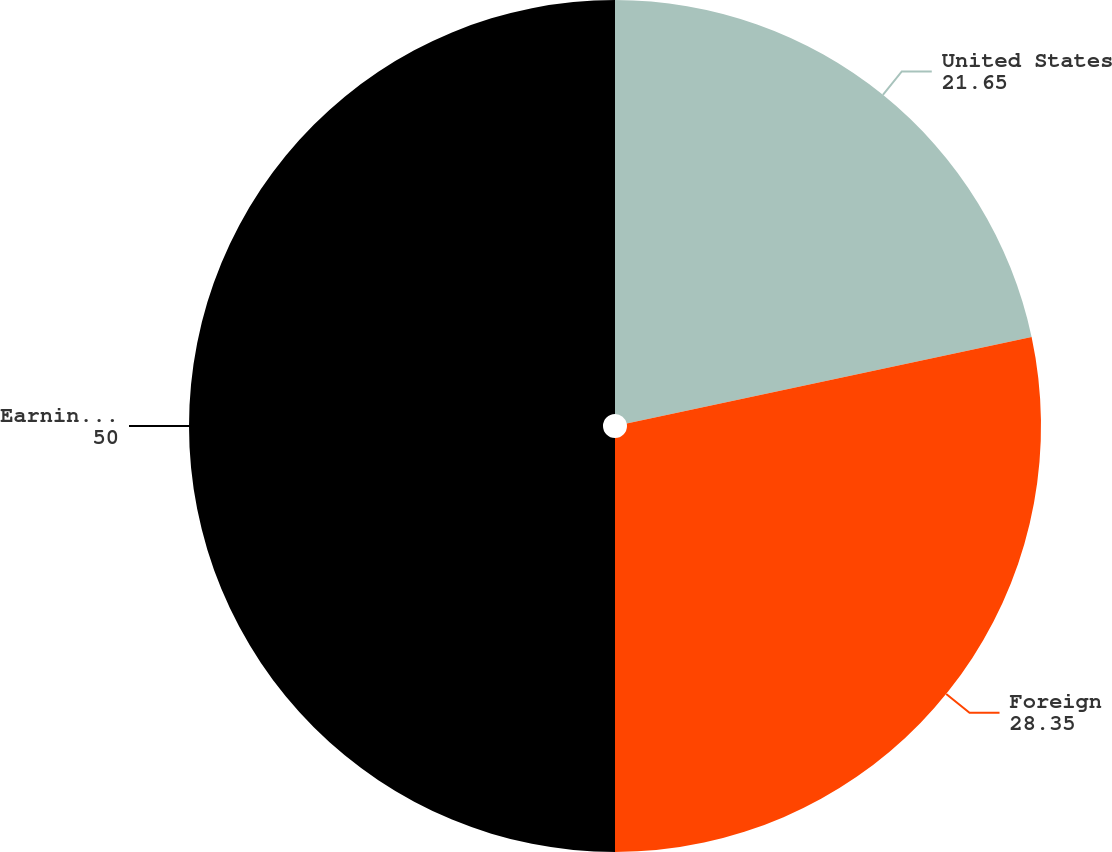Convert chart to OTSL. <chart><loc_0><loc_0><loc_500><loc_500><pie_chart><fcel>United States<fcel>Foreign<fcel>Earnings before income taxes<nl><fcel>21.65%<fcel>28.35%<fcel>50.0%<nl></chart> 